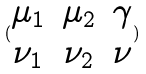Convert formula to latex. <formula><loc_0><loc_0><loc_500><loc_500>( \begin{matrix} \mu _ { 1 } & \mu _ { 2 } & \gamma \\ \nu _ { 1 } & \nu _ { 2 } & \nu \end{matrix} )</formula> 